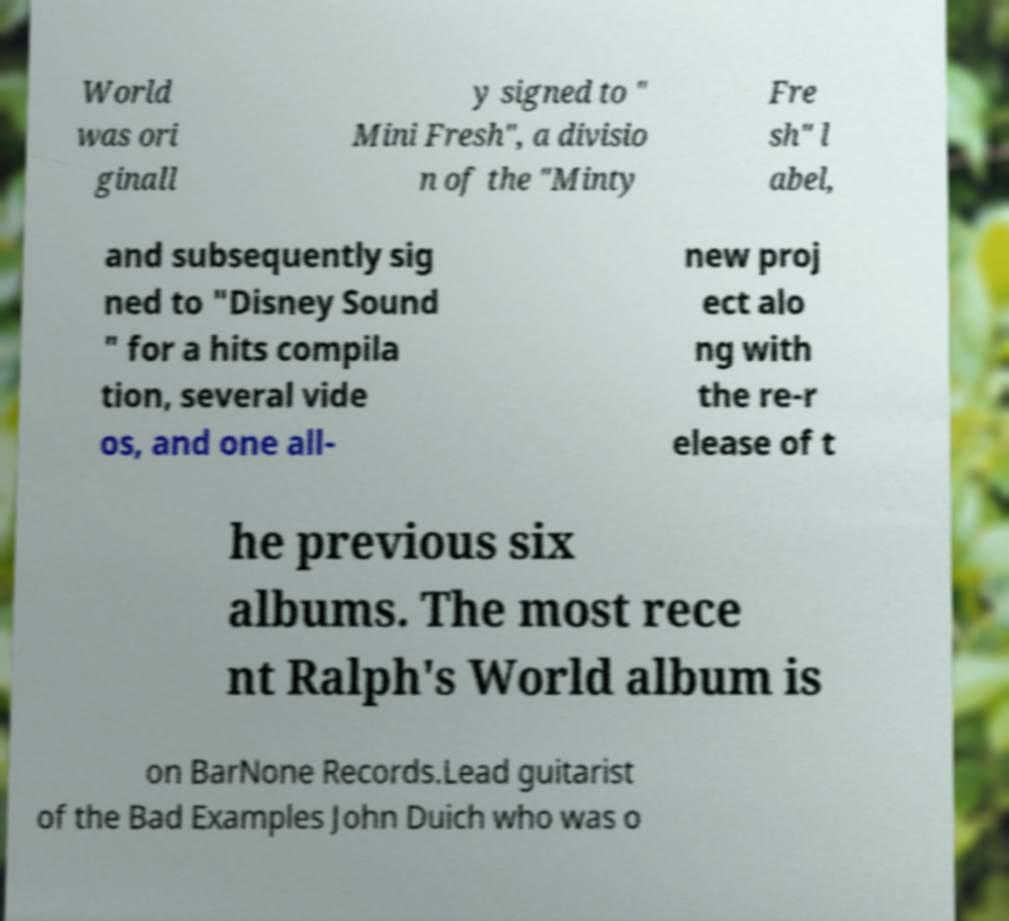Could you assist in decoding the text presented in this image and type it out clearly? World was ori ginall y signed to " Mini Fresh", a divisio n of the "Minty Fre sh" l abel, and subsequently sig ned to "Disney Sound " for a hits compila tion, several vide os, and one all- new proj ect alo ng with the re-r elease of t he previous six albums. The most rece nt Ralph's World album is on BarNone Records.Lead guitarist of the Bad Examples John Duich who was o 